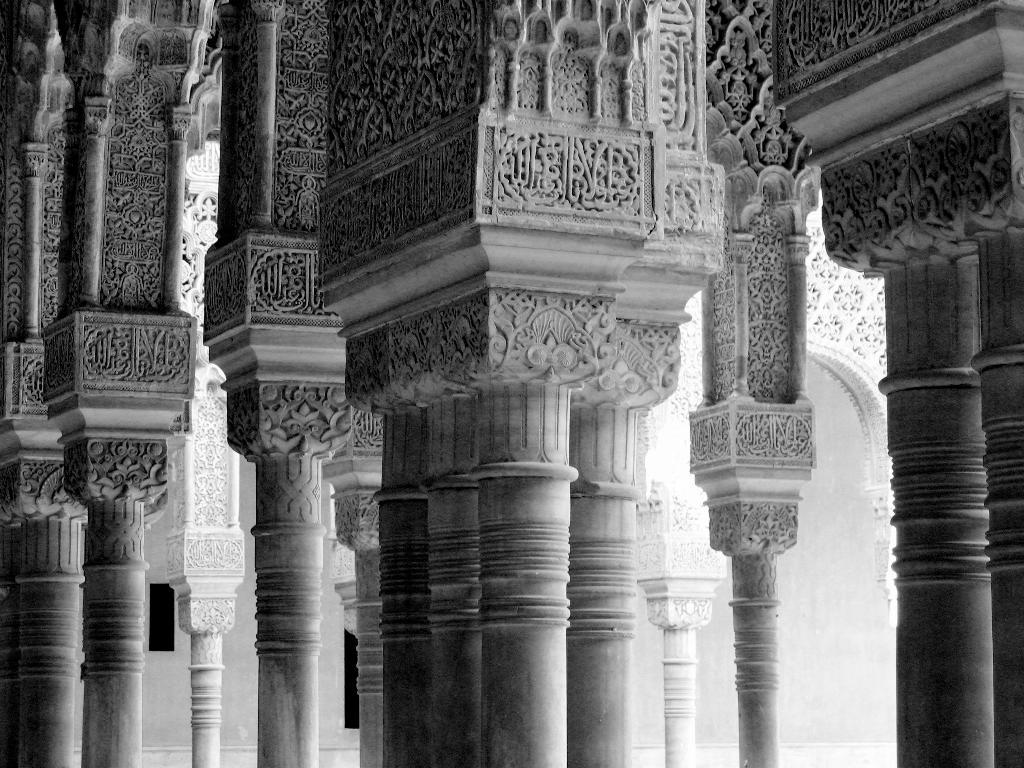What architectural features can be seen in the image? There are pillars in the image. What color scheme is used in the image? The image is in black and white color. What type of structure might the image depict? The image appears to depict a monument. What type of train can be seen passing by the monument in the image? There is no train present in the image; it only depicts a monument with pillars. What material is the bag made of that is placed on the monument in the image? There is no bag present in the image; it only depicts a monument with pillars. 